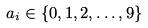Convert formula to latex. <formula><loc_0><loc_0><loc_500><loc_500>a _ { i } \in \{ 0 , 1 , 2 , \dots , 9 \}</formula> 